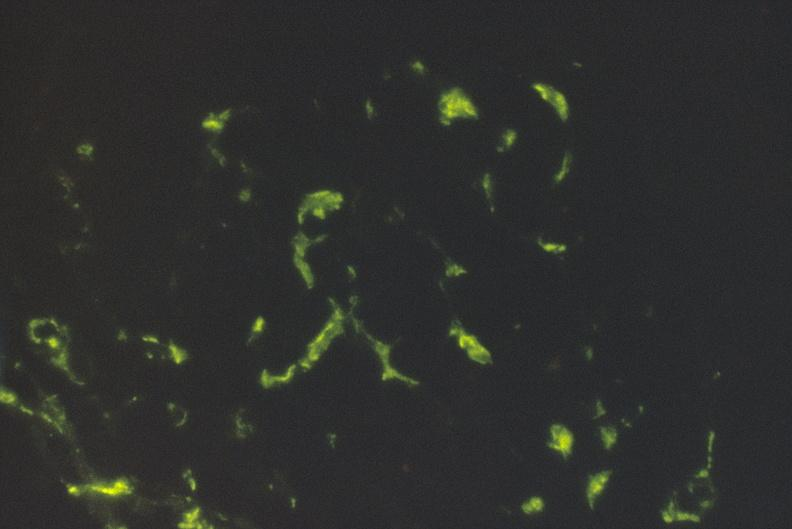s silver present?
Answer the question using a single word or phrase. No 